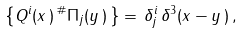<formula> <loc_0><loc_0><loc_500><loc_500>\left \{ Q ^ { i } ( x \, ) \, ^ { \# } \Pi _ { j } ( y \, ) \, \right \} = \, \delta ^ { i } _ { j } \, \delta ^ { 3 } ( x - y \, ) \, ,</formula> 